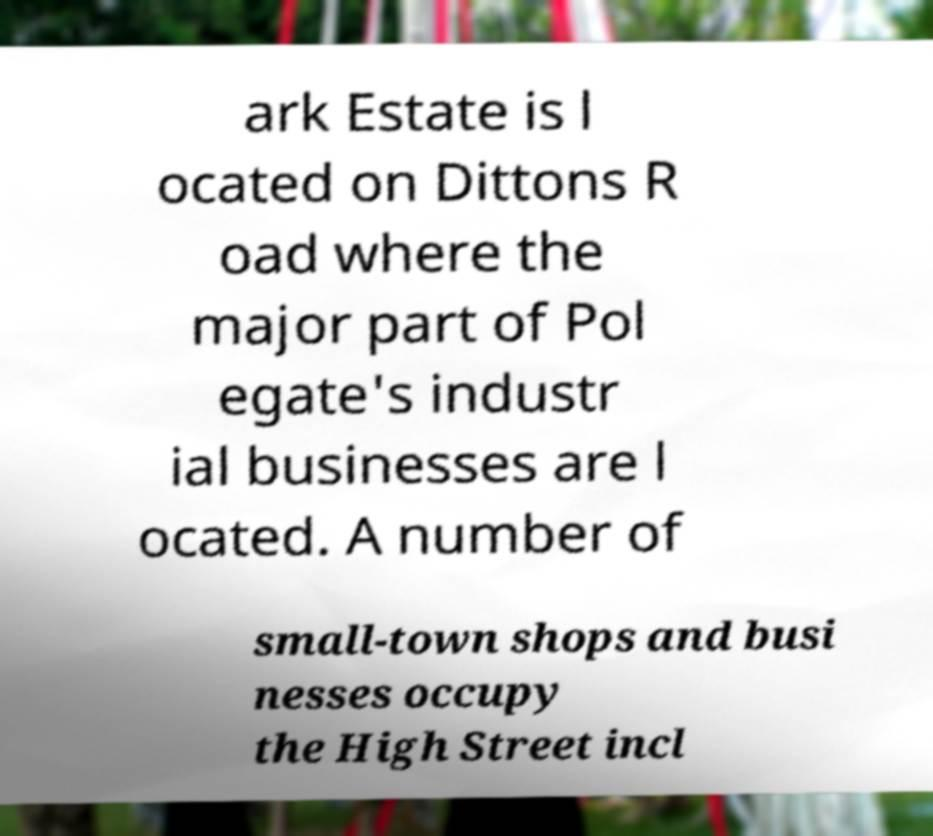Please identify and transcribe the text found in this image. ark Estate is l ocated on Dittons R oad where the major part of Pol egate's industr ial businesses are l ocated. A number of small-town shops and busi nesses occupy the High Street incl 